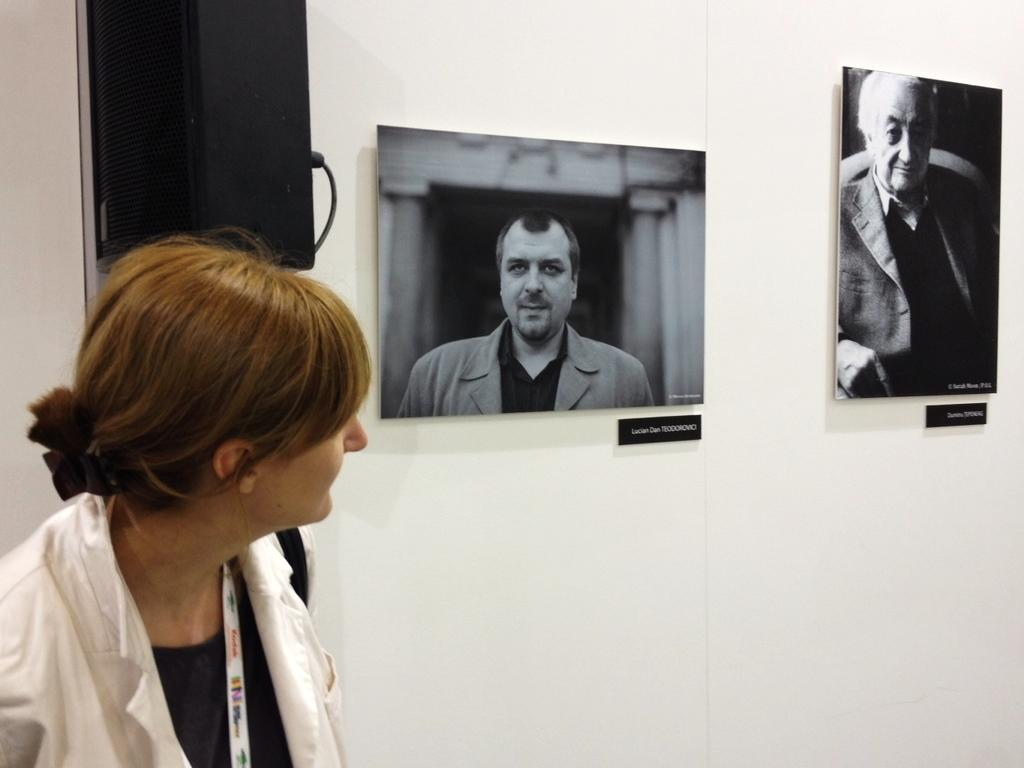Who or what is the main subject in the image? There is a person in the image. Where is the person located in relation to the wall? The person is in front of a wall. What can be seen in the top left of the image? There is a speaker in the top left of the image. What is hanging on the wall? There are photos on the wall. What type of toothpaste is the person using in the image? There is no toothpaste present in the image. How does the gate open in the image? There is no gate present in the image. 